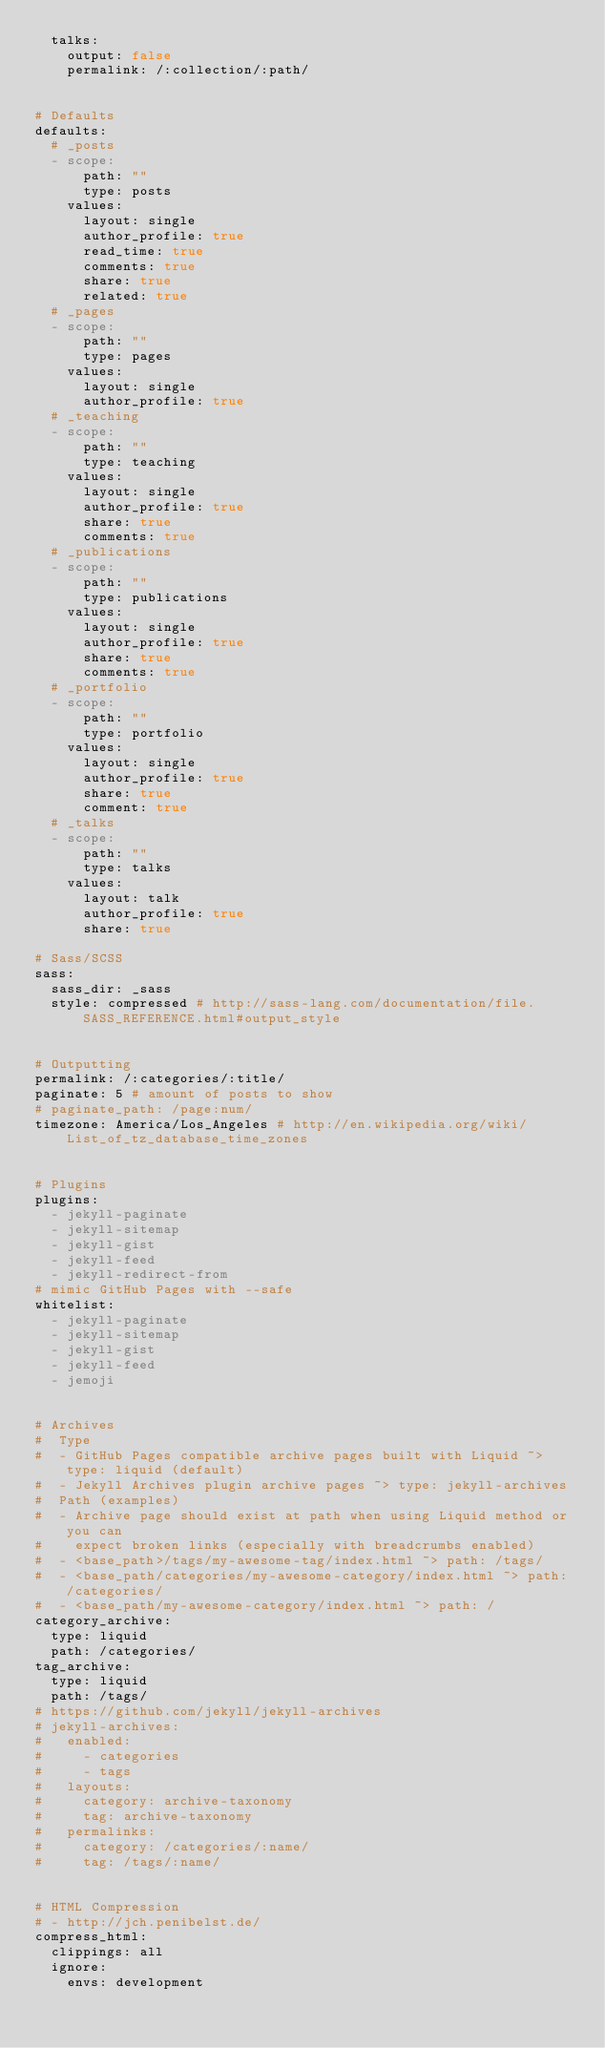<code> <loc_0><loc_0><loc_500><loc_500><_YAML_>  talks:
    output: false
    permalink: /:collection/:path/


# Defaults
defaults:
  # _posts
  - scope:
      path: ""
      type: posts
    values:
      layout: single
      author_profile: true
      read_time: true
      comments: true
      share: true
      related: true
  # _pages
  - scope:
      path: ""
      type: pages
    values:
      layout: single
      author_profile: true
  # _teaching
  - scope:
      path: ""
      type: teaching
    values:
      layout: single
      author_profile: true
      share: true
      comments: true
  # _publications
  - scope:
      path: ""
      type: publications
    values:
      layout: single
      author_profile: true
      share: true
      comments: true
  # _portfolio
  - scope:
      path: ""
      type: portfolio
    values:
      layout: single
      author_profile: true
      share: true
      comment: true
  # _talks
  - scope:
      path: ""
      type: talks
    values:
      layout: talk
      author_profile: true
      share: true

# Sass/SCSS
sass:
  sass_dir: _sass
  style: compressed # http://sass-lang.com/documentation/file.SASS_REFERENCE.html#output_style


# Outputting
permalink: /:categories/:title/
paginate: 5 # amount of posts to show
# paginate_path: /page:num/
timezone: America/Los_Angeles # http://en.wikipedia.org/wiki/List_of_tz_database_time_zones


# Plugins
plugins:
  - jekyll-paginate
  - jekyll-sitemap
  - jekyll-gist
  - jekyll-feed
  - jekyll-redirect-from
# mimic GitHub Pages with --safe
whitelist:
  - jekyll-paginate
  - jekyll-sitemap
  - jekyll-gist
  - jekyll-feed
  - jemoji


# Archives
#  Type
#  - GitHub Pages compatible archive pages built with Liquid ~> type: liquid (default)
#  - Jekyll Archives plugin archive pages ~> type: jekyll-archives
#  Path (examples)
#  - Archive page should exist at path when using Liquid method or you can
#    expect broken links (especially with breadcrumbs enabled)
#  - <base_path>/tags/my-awesome-tag/index.html ~> path: /tags/
#  - <base_path/categories/my-awesome-category/index.html ~> path: /categories/
#  - <base_path/my-awesome-category/index.html ~> path: /
category_archive:
  type: liquid
  path: /categories/
tag_archive:
  type: liquid
  path: /tags/
# https://github.com/jekyll/jekyll-archives
# jekyll-archives:
#   enabled:
#     - categories
#     - tags
#   layouts:
#     category: archive-taxonomy
#     tag: archive-taxonomy
#   permalinks:
#     category: /categories/:name/
#     tag: /tags/:name/


# HTML Compression
# - http://jch.penibelst.de/
compress_html:
  clippings: all
  ignore:
    envs: development
</code> 